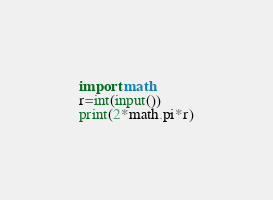<code> <loc_0><loc_0><loc_500><loc_500><_Python_>import math
r=int(input())
print(2*math.pi*r)</code> 